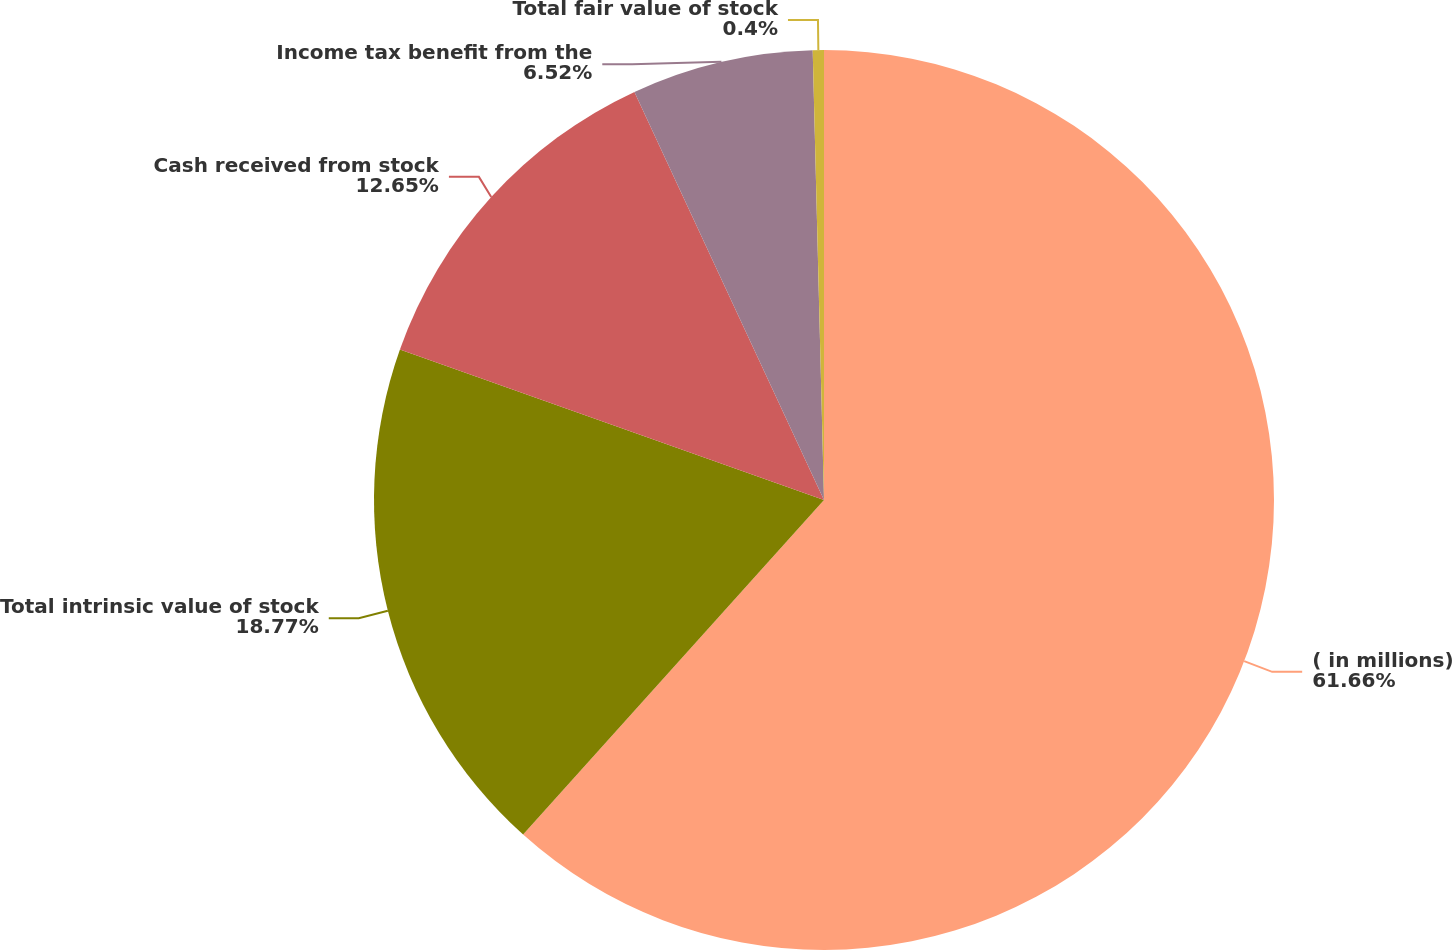Convert chart to OTSL. <chart><loc_0><loc_0><loc_500><loc_500><pie_chart><fcel>( in millions)<fcel>Total intrinsic value of stock<fcel>Cash received from stock<fcel>Income tax benefit from the<fcel>Total fair value of stock<nl><fcel>61.65%<fcel>18.77%<fcel>12.65%<fcel>6.52%<fcel>0.4%<nl></chart> 